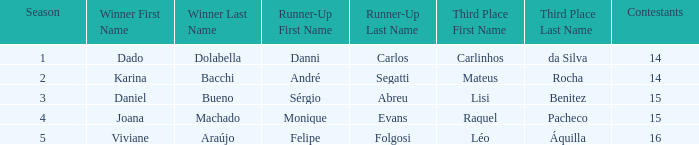In what season was the winner Dado Dolabella? 1.0. Parse the table in full. {'header': ['Season', 'Winner First Name', 'Winner Last Name', 'Runner-Up First Name', 'Runner-Up Last Name', 'Third Place First Name', 'Third Place Last Name', 'Contestants'], 'rows': [['1', 'Dado', 'Dolabella', 'Danni', 'Carlos', 'Carlinhos', 'da Silva', '14'], ['2', 'Karina', 'Bacchi', 'André', 'Segatti', 'Mateus', 'Rocha', '14'], ['3', 'Daniel', 'Bueno', 'Sérgio', 'Abreu', 'Lisi', 'Benitez', '15'], ['4', 'Joana', 'Machado', 'Monique', 'Evans', 'Raquel', 'Pacheco', '15'], ['5', 'Viviane', 'Araújo', 'Felipe', 'Folgosi', 'Léo', 'Áquilla', '16']]} 